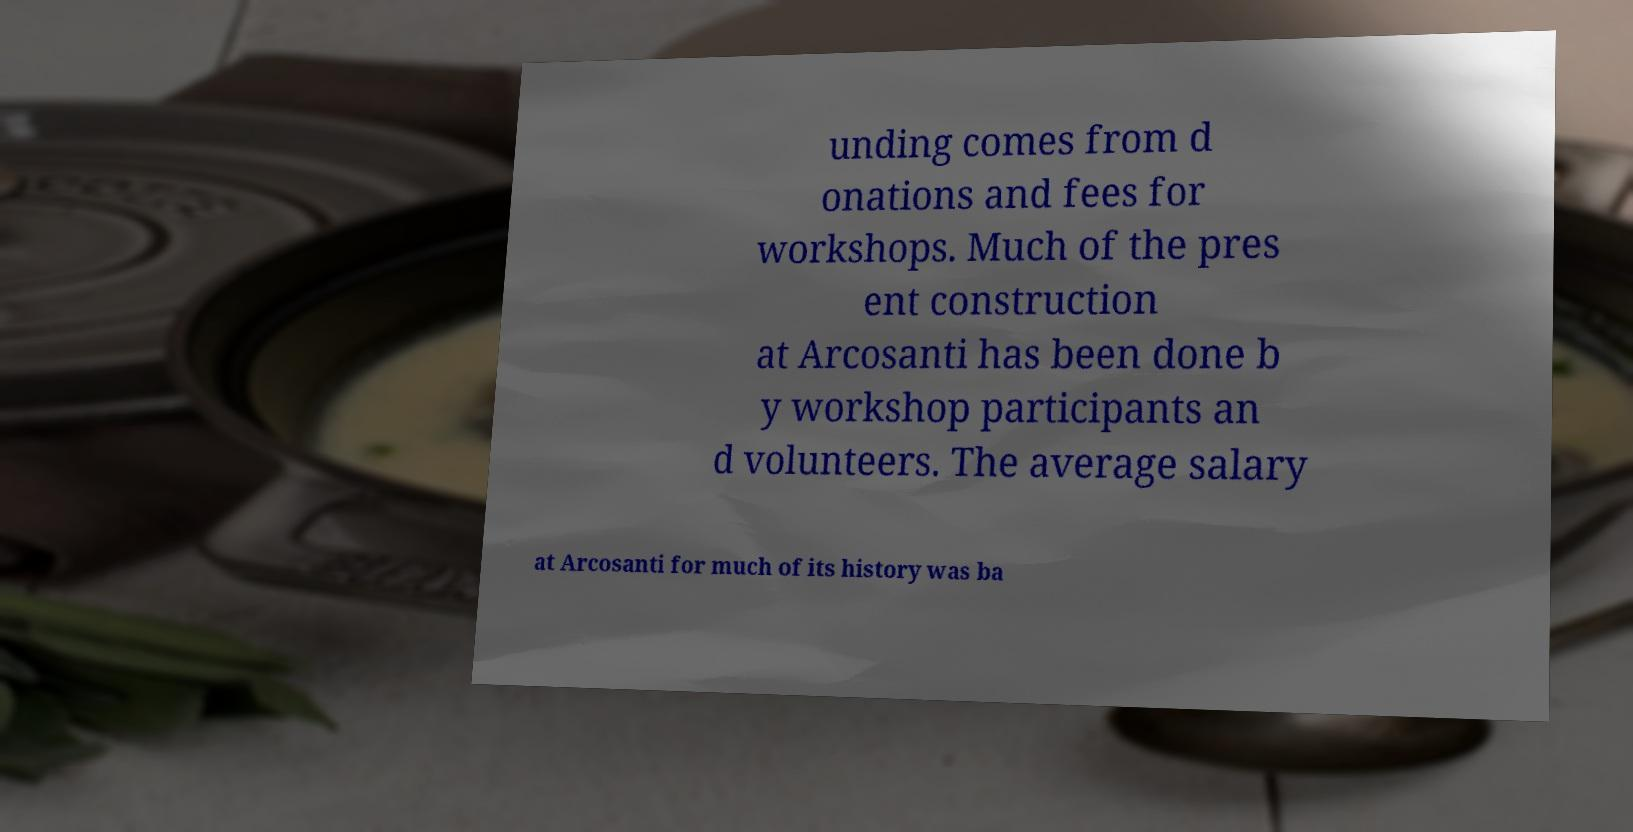Can you read and provide the text displayed in the image?This photo seems to have some interesting text. Can you extract and type it out for me? unding comes from d onations and fees for workshops. Much of the pres ent construction at Arcosanti has been done b y workshop participants an d volunteers. The average salary at Arcosanti for much of its history was ba 